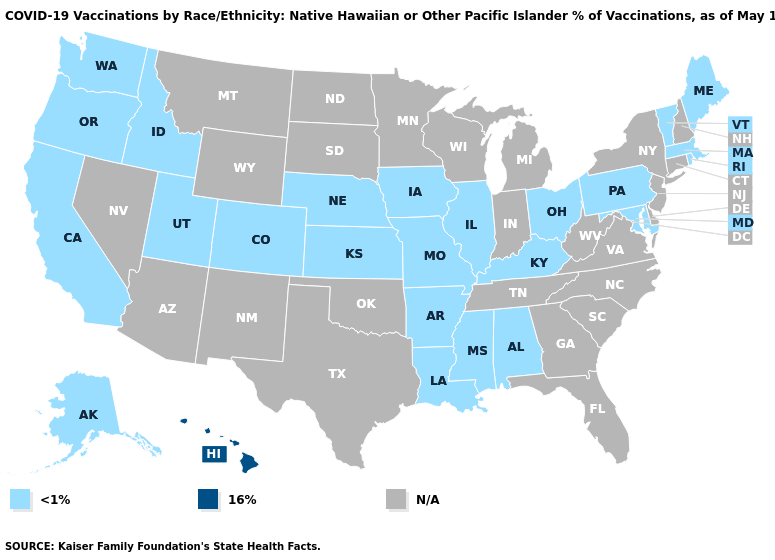Name the states that have a value in the range <1%?
Be succinct. Alabama, Alaska, Arkansas, California, Colorado, Idaho, Illinois, Iowa, Kansas, Kentucky, Louisiana, Maine, Maryland, Massachusetts, Mississippi, Missouri, Nebraska, Ohio, Oregon, Pennsylvania, Rhode Island, Utah, Vermont, Washington. Does Missouri have the lowest value in the USA?
Keep it brief. Yes. Name the states that have a value in the range 16%?
Concise answer only. Hawaii. Does Hawaii have the highest value in the USA?
Concise answer only. Yes. Is the legend a continuous bar?
Be succinct. No. What is the lowest value in states that border Ohio?
Give a very brief answer. <1%. Which states have the lowest value in the MidWest?
Quick response, please. Illinois, Iowa, Kansas, Missouri, Nebraska, Ohio. What is the highest value in the South ?
Write a very short answer. <1%. What is the value of Virginia?
Concise answer only. N/A. What is the highest value in states that border Nebraska?
Short answer required. <1%. Name the states that have a value in the range <1%?
Keep it brief. Alabama, Alaska, Arkansas, California, Colorado, Idaho, Illinois, Iowa, Kansas, Kentucky, Louisiana, Maine, Maryland, Massachusetts, Mississippi, Missouri, Nebraska, Ohio, Oregon, Pennsylvania, Rhode Island, Utah, Vermont, Washington. What is the value of Minnesota?
Concise answer only. N/A. Which states have the highest value in the USA?
Short answer required. Hawaii. 